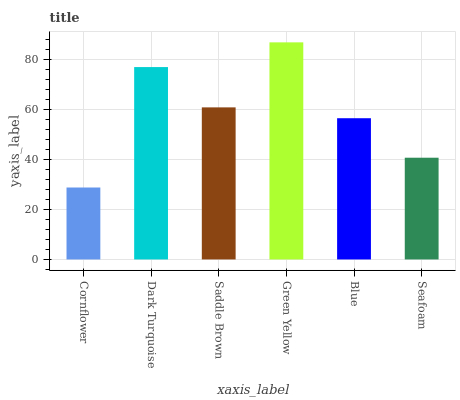Is Cornflower the minimum?
Answer yes or no. Yes. Is Green Yellow the maximum?
Answer yes or no. Yes. Is Dark Turquoise the minimum?
Answer yes or no. No. Is Dark Turquoise the maximum?
Answer yes or no. No. Is Dark Turquoise greater than Cornflower?
Answer yes or no. Yes. Is Cornflower less than Dark Turquoise?
Answer yes or no. Yes. Is Cornflower greater than Dark Turquoise?
Answer yes or no. No. Is Dark Turquoise less than Cornflower?
Answer yes or no. No. Is Saddle Brown the high median?
Answer yes or no. Yes. Is Blue the low median?
Answer yes or no. Yes. Is Dark Turquoise the high median?
Answer yes or no. No. Is Cornflower the low median?
Answer yes or no. No. 